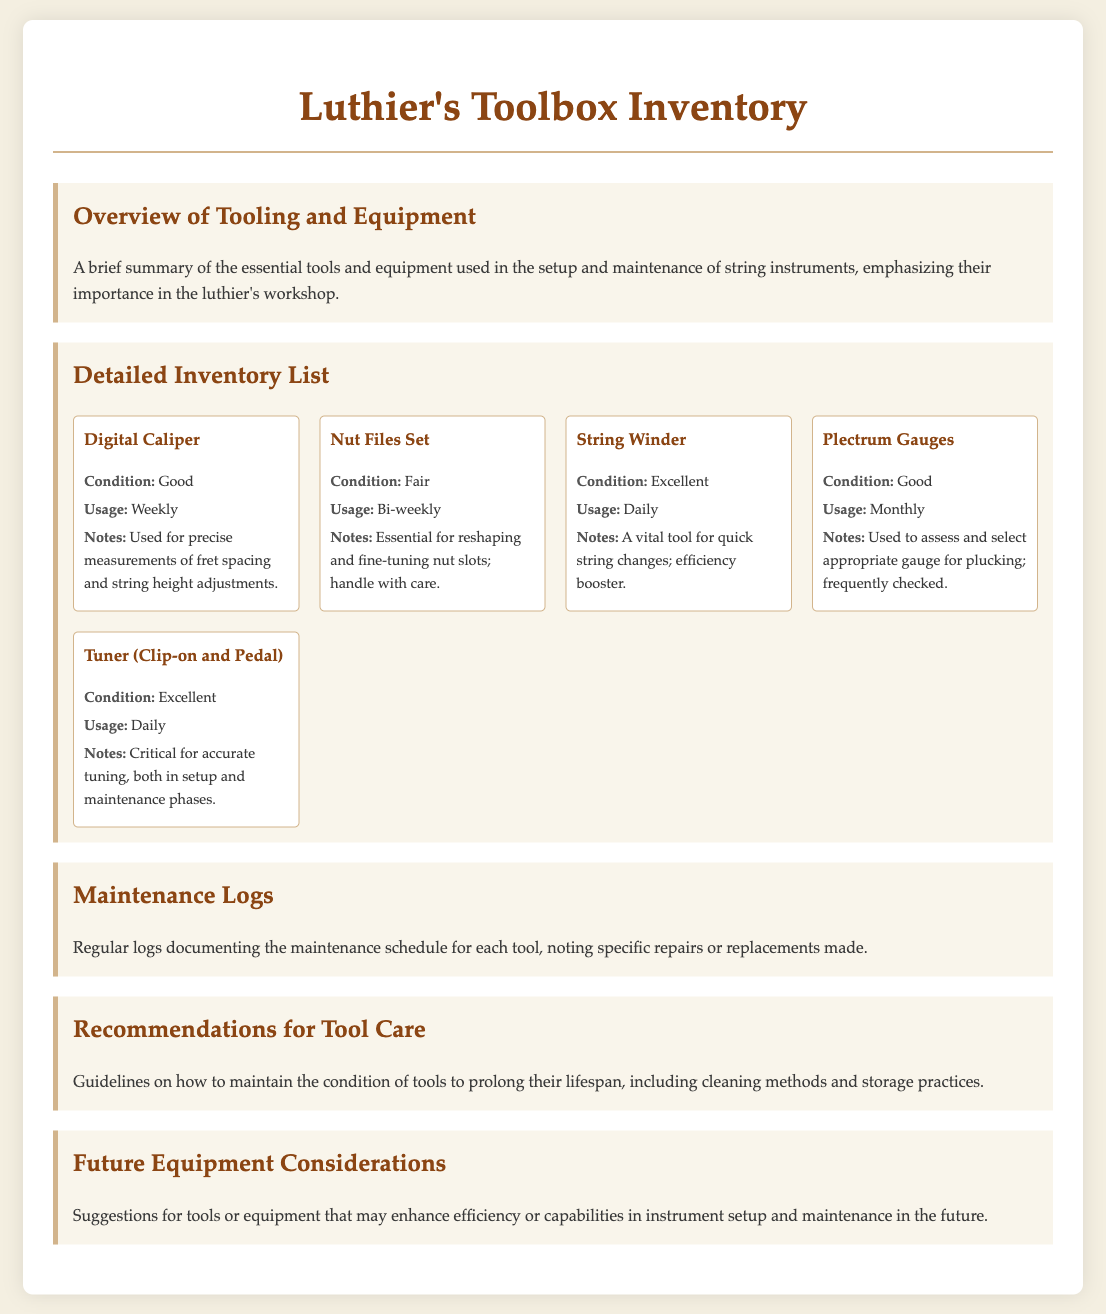what is the condition of the Digital Caliper? The condition of the Digital Caliper is specified as "Good" in the inventory list.
Answer: Good how often is the String Winder used? The frequency of usage for the String Winder is indicated as "Daily" in the inventory list.
Answer: Daily what is the condition of the Nut Files Set? The inventory report states that the condition of the Nut Files Set is "Fair."
Answer: Fair when was the last time Plectrum Gauges were used? The usage frequency of Plectrum Gauges is noted as "Monthly," suggesting the last use was within the last month.
Answer: Monthly what should one note about the String Winder? The notes mention that the String Winder is a "vital tool for quick string changes; efficiency booster."
Answer: vital tool for quick string changes; efficiency booster which tools are used daily? The tools used daily according to the inventory list are the String Winder and the Tuner.
Answer: String Winder and Tuner what recommendations does the document make for tools? Guidelines for maintaining the condition of tools are included in the "Recommendations for Tool Care" section of the document.
Answer: Recommendations for Tool Care which tool is mentioned for accurate tuning? The Tuner is specifically noted as critical for accurate tuning in both setup and maintenance phases.
Answer: Tuner how many times a month are the Plectrum Gauges used? The usage frequency for Plectrum Gauges is specified as "Monthly."
Answer: Monthly 